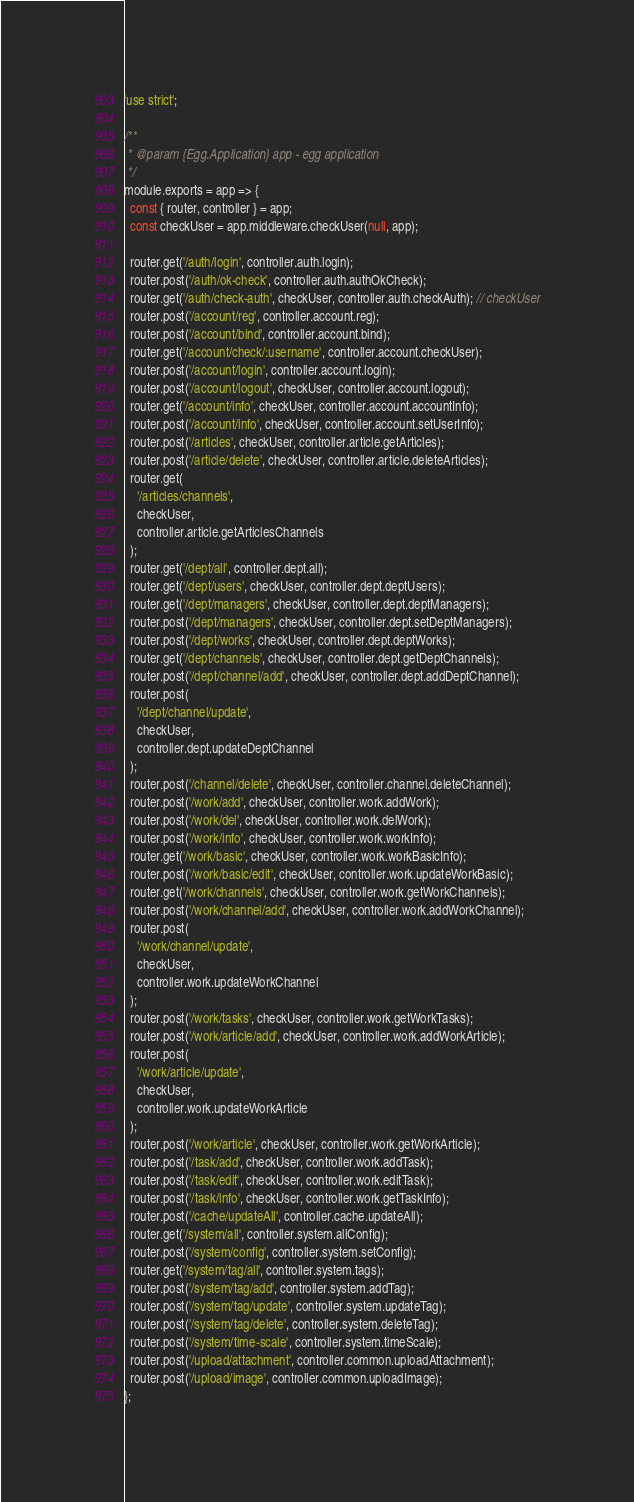Convert code to text. <code><loc_0><loc_0><loc_500><loc_500><_JavaScript_>'use strict';

/**
 * @param {Egg.Application} app - egg application
 */
module.exports = app => {
  const { router, controller } = app;
  const checkUser = app.middleware.checkUser(null, app);

  router.get('/auth/login', controller.auth.login);
  router.post('/auth/ok-check', controller.auth.authOkCheck);
  router.get('/auth/check-auth', checkUser, controller.auth.checkAuth); // checkUser
  router.post('/account/reg', controller.account.reg);
  router.post('/account/bind', controller.account.bind);
  router.get('/account/check/:username', controller.account.checkUser);
  router.post('/account/login', controller.account.login);
  router.post('/account/logout', checkUser, controller.account.logout);
  router.get('/account/info', checkUser, controller.account.accountInfo);
  router.post('/account/info', checkUser, controller.account.setUserInfo);
  router.post('/articles', checkUser, controller.article.getArticles);
  router.post('/article/delete', checkUser, controller.article.deleteArticles);
  router.get(
    '/articles/channels',
    checkUser,
    controller.article.getArticlesChannels
  );
  router.get('/dept/all', controller.dept.all);
  router.get('/dept/users', checkUser, controller.dept.deptUsers);
  router.get('/dept/managers', checkUser, controller.dept.deptManagers);
  router.post('/dept/managers', checkUser, controller.dept.setDeptManagers);
  router.post('/dept/works', checkUser, controller.dept.deptWorks);
  router.get('/dept/channels', checkUser, controller.dept.getDeptChannels);
  router.post('/dept/channel/add', checkUser, controller.dept.addDeptChannel);
  router.post(
    '/dept/channel/update',
    checkUser,
    controller.dept.updateDeptChannel
  );
  router.post('/channel/delete', checkUser, controller.channel.deleteChannel);
  router.post('/work/add', checkUser, controller.work.addWork);
  router.post('/work/del', checkUser, controller.work.delWork);
  router.post('/work/info', checkUser, controller.work.workInfo);
  router.get('/work/basic', checkUser, controller.work.workBasicInfo);
  router.post('/work/basic/edit', checkUser, controller.work.updateWorkBasic);
  router.get('/work/channels', checkUser, controller.work.getWorkChannels);
  router.post('/work/channel/add', checkUser, controller.work.addWorkChannel);
  router.post(
    '/work/channel/update',
    checkUser,
    controller.work.updateWorkChannel
  );
  router.post('/work/tasks', checkUser, controller.work.getWorkTasks);
  router.post('/work/article/add', checkUser, controller.work.addWorkArticle);
  router.post(
    '/work/article/update',
    checkUser,
    controller.work.updateWorkArticle
  );
  router.post('/work/article', checkUser, controller.work.getWorkArticle);
  router.post('/task/add', checkUser, controller.work.addTask);
  router.post('/task/edit', checkUser, controller.work.editTask);
  router.post('/task/info', checkUser, controller.work.getTaskInfo);
  router.post('/cache/updateAll', controller.cache.updateAll);
  router.get('/system/all', controller.system.allConfig);
  router.post('/system/config', controller.system.setConfig);
  router.get('/system/tag/all', controller.system.tags);
  router.post('/system/tag/add', controller.system.addTag);
  router.post('/system/tag/update', controller.system.updateTag);
  router.post('/system/tag/delete', controller.system.deleteTag);
  router.post('/system/time-scale', controller.system.timeScale);
  router.post('/upload/attachment', controller.common.uploadAttachment);
  router.post('/upload/image', controller.common.uploadImage);
};
</code> 